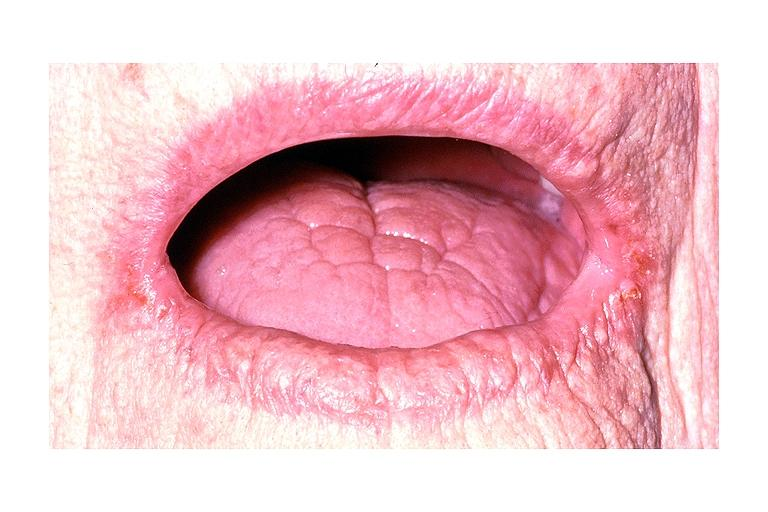s oral present?
Answer the question using a single word or phrase. Yes 